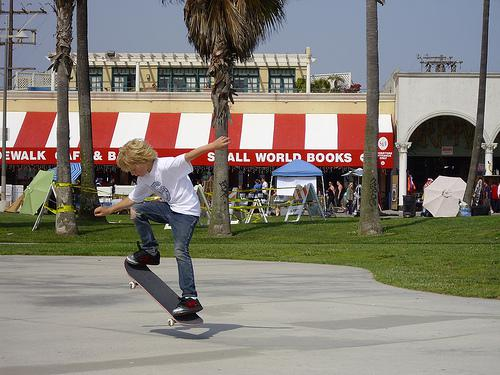Question: who is on a skateboard?
Choices:
A. The girl.
B. A man.
C. The dog.
D. A boy.
Answer with the letter. Answer: D Question: what is black?
Choices:
A. Surfboard.
B. Baseball bat.
C. Wetsuit.
D. Skateboard.
Answer with the letter. Answer: D Question: what is blue?
Choices:
A. Car.
B. Sky.
C. Water.
D. Billboard.
Answer with the letter. Answer: B Question: what is green?
Choices:
A. Car.
B. House.
C. Grass.
D. Plants.
Answer with the letter. Answer: C Question: who is wearing a white shirt?
Choices:
A. Surfer.
B. Baseball player.
C. Skateboarder.
D. Tennis player.
Answer with the letter. Answer: C Question: where are wheels?
Choices:
A. On the motorcycle.
B. On a skateboard.
C. On the wagon.
D. On the car.
Answer with the letter. Answer: B Question: how many boys are skateboarding?
Choices:
A. One.
B. Two.
C. Three.
D. Four.
Answer with the letter. Answer: A 